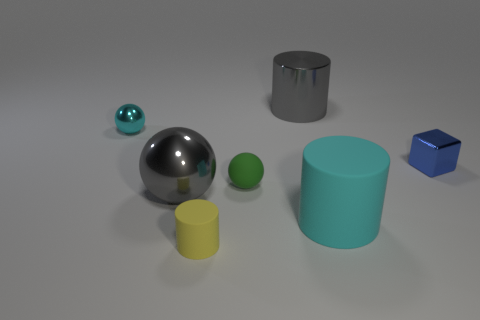Is there a green sphere that has the same size as the cyan shiny sphere?
Make the answer very short. Yes. What color is the other tiny metallic thing that is the same shape as the small green thing?
Your response must be concise. Cyan. There is a sphere that is behind the tiny cube; does it have the same size as the matte object that is to the left of the tiny matte ball?
Keep it short and to the point. Yes. Are there any other shiny objects of the same shape as the big cyan object?
Offer a terse response. Yes. Is the number of tiny matte cylinders behind the tiny blue shiny thing the same as the number of blue blocks?
Give a very brief answer. No. Does the blue metal cube have the same size as the cyan object that is right of the big gray cylinder?
Offer a very short reply. No. What number of yellow balls are the same material as the large gray sphere?
Keep it short and to the point. 0. Does the cyan sphere have the same size as the green thing?
Provide a short and direct response. Yes. Is there any other thing of the same color as the block?
Offer a very short reply. No. There is a large object that is both in front of the shiny cube and to the left of the large cyan thing; what is its shape?
Ensure brevity in your answer.  Sphere. 